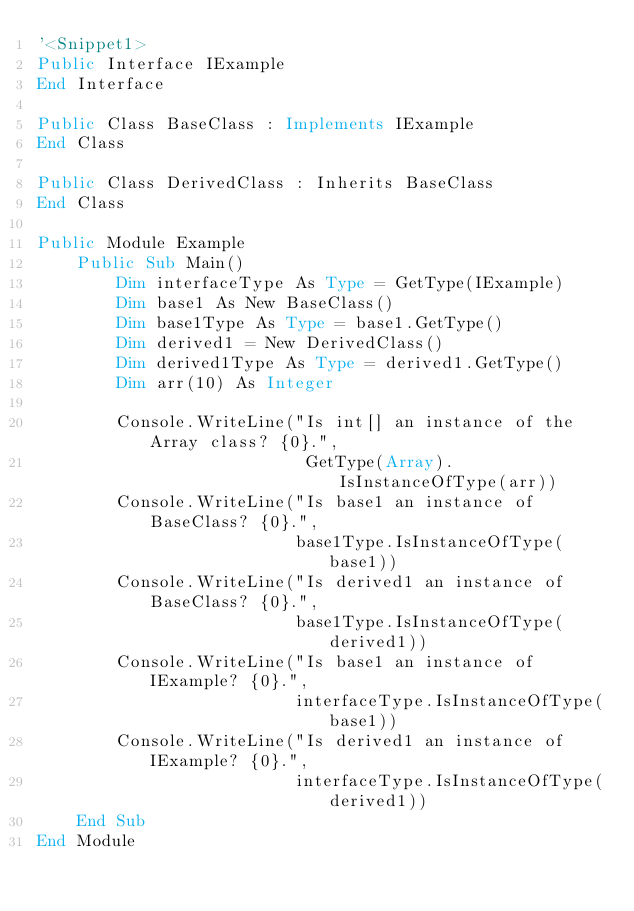Convert code to text. <code><loc_0><loc_0><loc_500><loc_500><_VisualBasic_>'<Snippet1>
Public Interface IExample
End Interface

Public Class BaseClass : Implements IExample
End Class

Public Class DerivedClass : Inherits BaseClass
End Class

Public Module Example
    Public Sub Main()
        Dim interfaceType As Type = GetType(IExample)
        Dim base1 As New BaseClass()
        Dim base1Type As Type = base1.GetType()
        Dim derived1 = New DerivedClass()
        Dim derived1Type As Type = derived1.GetType()
        Dim arr(10) As Integer

        Console.WriteLine("Is int[] an instance of the Array class? {0}.",
                           GetType(Array).IsInstanceOfType(arr))
        Console.WriteLine("Is base1 an instance of BaseClass? {0}.",
                          base1Type.IsInstanceOfType(base1))
        Console.WriteLine("Is derived1 an instance of BaseClass? {0}.",
                          base1Type.IsInstanceOfType(derived1))
        Console.WriteLine("Is base1 an instance of IExample? {0}.",
                          interfaceType.IsInstanceOfType(base1))
        Console.WriteLine("Is derived1 an instance of IExample? {0}.",
                          interfaceType.IsInstanceOfType(derived1))
    End Sub
End Module</code> 